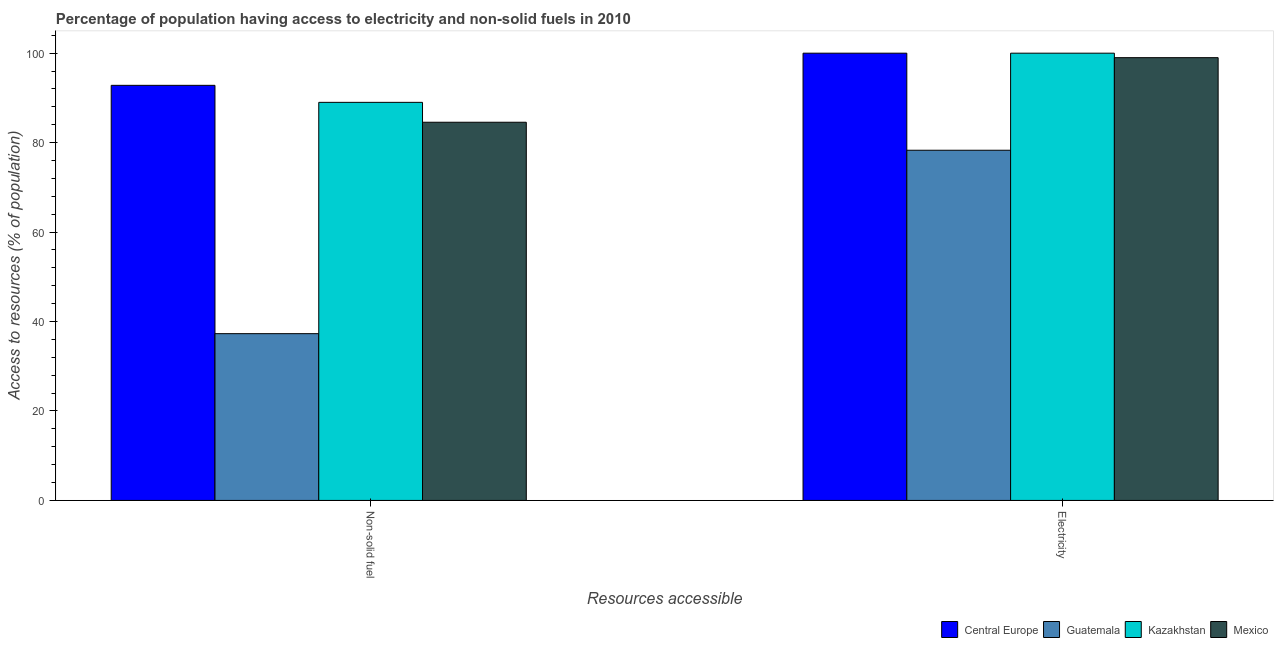How many groups of bars are there?
Offer a terse response. 2. Are the number of bars per tick equal to the number of legend labels?
Give a very brief answer. Yes. How many bars are there on the 2nd tick from the left?
Keep it short and to the point. 4. What is the label of the 1st group of bars from the left?
Offer a very short reply. Non-solid fuel. Across all countries, what is the maximum percentage of population having access to electricity?
Offer a terse response. 100. Across all countries, what is the minimum percentage of population having access to non-solid fuel?
Make the answer very short. 37.29. In which country was the percentage of population having access to non-solid fuel maximum?
Your response must be concise. Central Europe. In which country was the percentage of population having access to non-solid fuel minimum?
Provide a succinct answer. Guatemala. What is the total percentage of population having access to non-solid fuel in the graph?
Ensure brevity in your answer.  303.67. What is the difference between the percentage of population having access to electricity in Mexico and that in Guatemala?
Give a very brief answer. 20.7. What is the difference between the percentage of population having access to non-solid fuel in Kazakhstan and the percentage of population having access to electricity in Central Europe?
Your answer should be compact. -10.99. What is the average percentage of population having access to electricity per country?
Offer a terse response. 94.33. What is the difference between the percentage of population having access to non-solid fuel and percentage of population having access to electricity in Central Europe?
Your response must be concise. -7.19. What is the ratio of the percentage of population having access to non-solid fuel in Central Europe to that in Mexico?
Ensure brevity in your answer.  1.1. In how many countries, is the percentage of population having access to non-solid fuel greater than the average percentage of population having access to non-solid fuel taken over all countries?
Provide a succinct answer. 3. What does the 3rd bar from the left in Electricity represents?
Your answer should be compact. Kazakhstan. What does the 3rd bar from the right in Electricity represents?
Your answer should be compact. Guatemala. How many bars are there?
Offer a terse response. 8. How many countries are there in the graph?
Offer a very short reply. 4. Are the values on the major ticks of Y-axis written in scientific E-notation?
Offer a terse response. No. Does the graph contain any zero values?
Give a very brief answer. No. Does the graph contain grids?
Make the answer very short. No. Where does the legend appear in the graph?
Your response must be concise. Bottom right. How many legend labels are there?
Offer a very short reply. 4. How are the legend labels stacked?
Provide a short and direct response. Horizontal. What is the title of the graph?
Keep it short and to the point. Percentage of population having access to electricity and non-solid fuels in 2010. Does "Zimbabwe" appear as one of the legend labels in the graph?
Keep it short and to the point. No. What is the label or title of the X-axis?
Offer a very short reply. Resources accessible. What is the label or title of the Y-axis?
Your answer should be very brief. Access to resources (% of population). What is the Access to resources (% of population) in Central Europe in Non-solid fuel?
Provide a short and direct response. 92.81. What is the Access to resources (% of population) in Guatemala in Non-solid fuel?
Offer a terse response. 37.29. What is the Access to resources (% of population) in Kazakhstan in Non-solid fuel?
Your answer should be compact. 89.01. What is the Access to resources (% of population) in Mexico in Non-solid fuel?
Your answer should be compact. 84.56. What is the Access to resources (% of population) in Central Europe in Electricity?
Provide a succinct answer. 100. What is the Access to resources (% of population) of Guatemala in Electricity?
Make the answer very short. 78.3. Across all Resources accessible, what is the maximum Access to resources (% of population) in Guatemala?
Keep it short and to the point. 78.3. Across all Resources accessible, what is the maximum Access to resources (% of population) of Mexico?
Offer a very short reply. 99. Across all Resources accessible, what is the minimum Access to resources (% of population) in Central Europe?
Make the answer very short. 92.81. Across all Resources accessible, what is the minimum Access to resources (% of population) of Guatemala?
Keep it short and to the point. 37.29. Across all Resources accessible, what is the minimum Access to resources (% of population) in Kazakhstan?
Keep it short and to the point. 89.01. Across all Resources accessible, what is the minimum Access to resources (% of population) in Mexico?
Offer a very short reply. 84.56. What is the total Access to resources (% of population) of Central Europe in the graph?
Your response must be concise. 192.81. What is the total Access to resources (% of population) in Guatemala in the graph?
Provide a succinct answer. 115.59. What is the total Access to resources (% of population) in Kazakhstan in the graph?
Your answer should be compact. 189.01. What is the total Access to resources (% of population) of Mexico in the graph?
Your answer should be very brief. 183.56. What is the difference between the Access to resources (% of population) in Central Europe in Non-solid fuel and that in Electricity?
Your response must be concise. -7.19. What is the difference between the Access to resources (% of population) of Guatemala in Non-solid fuel and that in Electricity?
Keep it short and to the point. -41.01. What is the difference between the Access to resources (% of population) in Kazakhstan in Non-solid fuel and that in Electricity?
Keep it short and to the point. -10.99. What is the difference between the Access to resources (% of population) in Mexico in Non-solid fuel and that in Electricity?
Provide a succinct answer. -14.44. What is the difference between the Access to resources (% of population) of Central Europe in Non-solid fuel and the Access to resources (% of population) of Guatemala in Electricity?
Make the answer very short. 14.51. What is the difference between the Access to resources (% of population) of Central Europe in Non-solid fuel and the Access to resources (% of population) of Kazakhstan in Electricity?
Provide a succinct answer. -7.19. What is the difference between the Access to resources (% of population) of Central Europe in Non-solid fuel and the Access to resources (% of population) of Mexico in Electricity?
Your answer should be compact. -6.19. What is the difference between the Access to resources (% of population) in Guatemala in Non-solid fuel and the Access to resources (% of population) in Kazakhstan in Electricity?
Make the answer very short. -62.71. What is the difference between the Access to resources (% of population) of Guatemala in Non-solid fuel and the Access to resources (% of population) of Mexico in Electricity?
Give a very brief answer. -61.71. What is the difference between the Access to resources (% of population) in Kazakhstan in Non-solid fuel and the Access to resources (% of population) in Mexico in Electricity?
Give a very brief answer. -9.99. What is the average Access to resources (% of population) in Central Europe per Resources accessible?
Provide a short and direct response. 96.41. What is the average Access to resources (% of population) of Guatemala per Resources accessible?
Provide a short and direct response. 57.79. What is the average Access to resources (% of population) of Kazakhstan per Resources accessible?
Keep it short and to the point. 94.5. What is the average Access to resources (% of population) of Mexico per Resources accessible?
Provide a succinct answer. 91.78. What is the difference between the Access to resources (% of population) in Central Europe and Access to resources (% of population) in Guatemala in Non-solid fuel?
Your answer should be very brief. 55.52. What is the difference between the Access to resources (% of population) in Central Europe and Access to resources (% of population) in Kazakhstan in Non-solid fuel?
Give a very brief answer. 3.81. What is the difference between the Access to resources (% of population) in Central Europe and Access to resources (% of population) in Mexico in Non-solid fuel?
Offer a terse response. 8.25. What is the difference between the Access to resources (% of population) in Guatemala and Access to resources (% of population) in Kazakhstan in Non-solid fuel?
Provide a succinct answer. -51.72. What is the difference between the Access to resources (% of population) of Guatemala and Access to resources (% of population) of Mexico in Non-solid fuel?
Make the answer very short. -47.27. What is the difference between the Access to resources (% of population) in Kazakhstan and Access to resources (% of population) in Mexico in Non-solid fuel?
Your answer should be very brief. 4.45. What is the difference between the Access to resources (% of population) of Central Europe and Access to resources (% of population) of Guatemala in Electricity?
Provide a succinct answer. 21.7. What is the difference between the Access to resources (% of population) of Central Europe and Access to resources (% of population) of Mexico in Electricity?
Offer a terse response. 1. What is the difference between the Access to resources (% of population) of Guatemala and Access to resources (% of population) of Kazakhstan in Electricity?
Offer a very short reply. -21.7. What is the difference between the Access to resources (% of population) of Guatemala and Access to resources (% of population) of Mexico in Electricity?
Provide a short and direct response. -20.7. What is the difference between the Access to resources (% of population) of Kazakhstan and Access to resources (% of population) of Mexico in Electricity?
Your response must be concise. 1. What is the ratio of the Access to resources (% of population) in Central Europe in Non-solid fuel to that in Electricity?
Your response must be concise. 0.93. What is the ratio of the Access to resources (% of population) of Guatemala in Non-solid fuel to that in Electricity?
Your response must be concise. 0.48. What is the ratio of the Access to resources (% of population) of Kazakhstan in Non-solid fuel to that in Electricity?
Ensure brevity in your answer.  0.89. What is the ratio of the Access to resources (% of population) of Mexico in Non-solid fuel to that in Electricity?
Provide a short and direct response. 0.85. What is the difference between the highest and the second highest Access to resources (% of population) of Central Europe?
Offer a very short reply. 7.19. What is the difference between the highest and the second highest Access to resources (% of population) in Guatemala?
Ensure brevity in your answer.  41.01. What is the difference between the highest and the second highest Access to resources (% of population) of Kazakhstan?
Offer a very short reply. 10.99. What is the difference between the highest and the second highest Access to resources (% of population) of Mexico?
Provide a short and direct response. 14.44. What is the difference between the highest and the lowest Access to resources (% of population) of Central Europe?
Make the answer very short. 7.19. What is the difference between the highest and the lowest Access to resources (% of population) in Guatemala?
Your response must be concise. 41.01. What is the difference between the highest and the lowest Access to resources (% of population) in Kazakhstan?
Your answer should be compact. 10.99. What is the difference between the highest and the lowest Access to resources (% of population) of Mexico?
Provide a short and direct response. 14.44. 